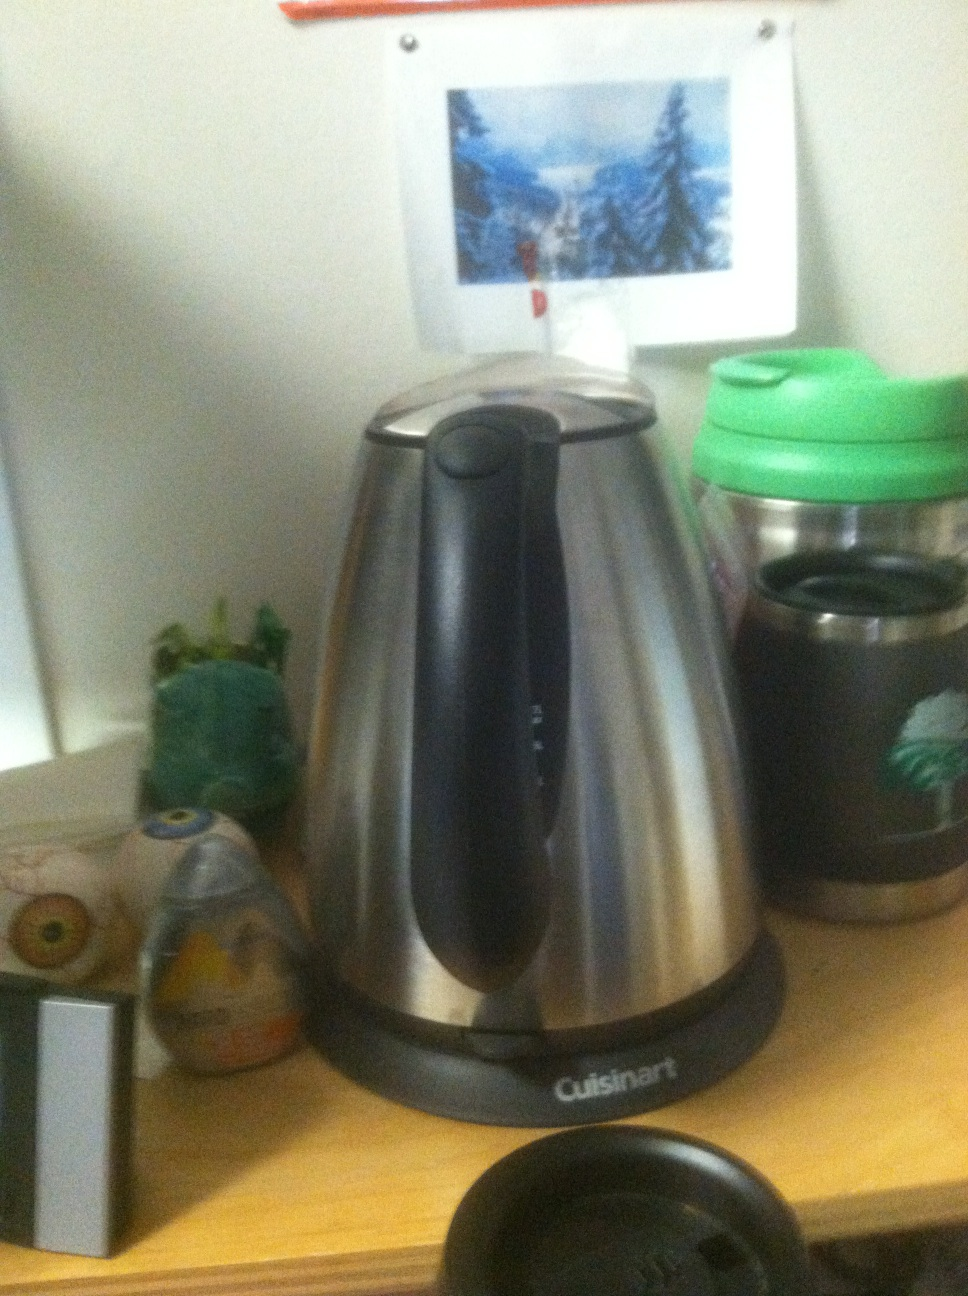What is this? What is this? from Vizwiz This is a Cuisinart brand coffee pot, distinguished by its sleek stainless steel finish and sturdy design. It appears to be well-used, suggesting it's a reliable appliance in a setting that might be an office or a busy home kitchen. 